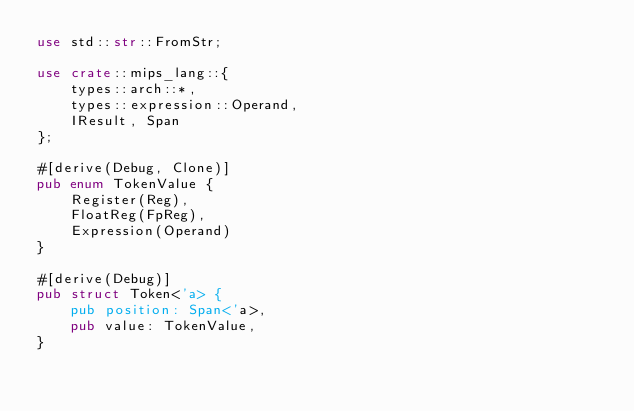<code> <loc_0><loc_0><loc_500><loc_500><_Rust_>use std::str::FromStr;

use crate::mips_lang::{
    types::arch::*,
    types::expression::Operand,
    IResult, Span
};

#[derive(Debug, Clone)]
pub enum TokenValue {
    Register(Reg),
    FloatReg(FpReg),
    Expression(Operand)
}

#[derive(Debug)]
pub struct Token<'a> {
    pub position: Span<'a>,
    pub value: TokenValue,
}

</code> 